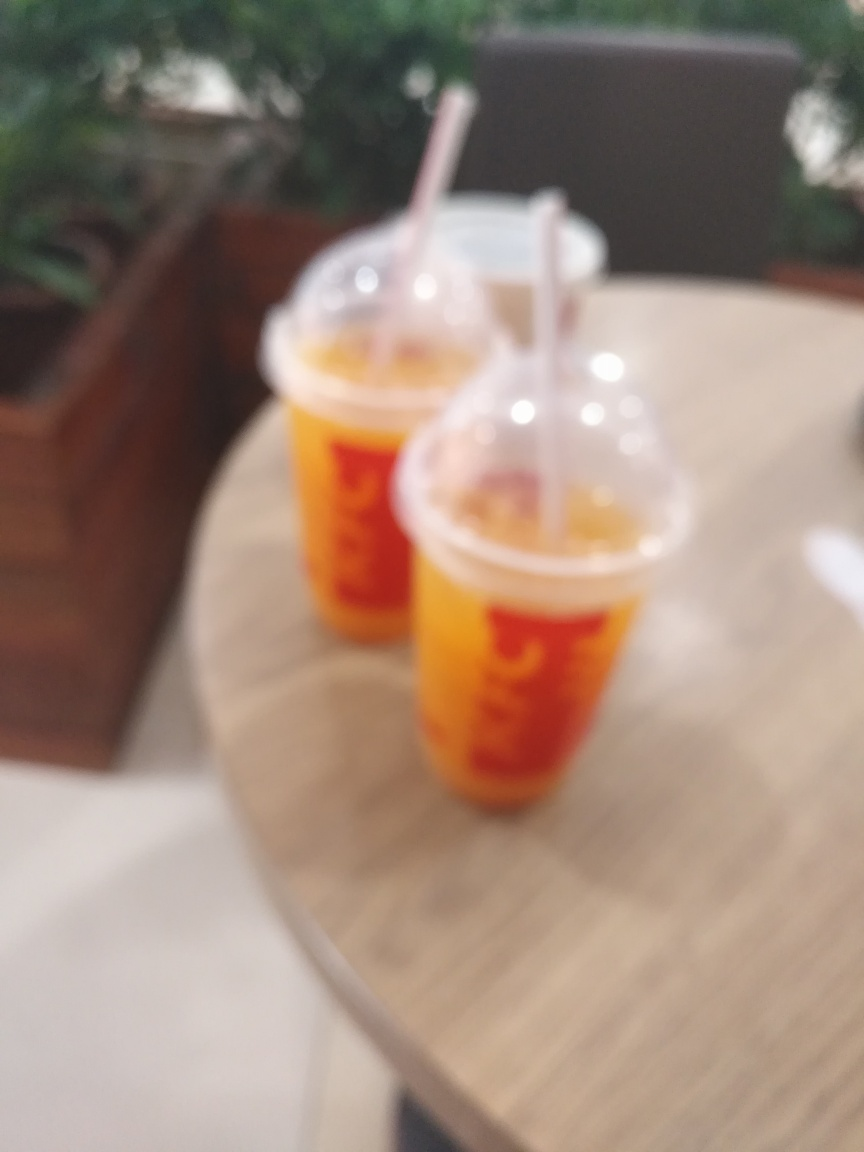What could be the possible reasons for the image being blurred? One likely reason for the image's blurriness could be an unintentional camera shake during the exposure, especially if a slow shutter speed was used. Alternatively, it could be a result of incorrect focus, where the camera's autofocus might have locked onto the wrong subject or failed to find a subject, which is common in close-up photography without macro settings. Lastly, it's possible that the blur is an artistic choice to emphasize a sense of movement or to create a specific mood. 